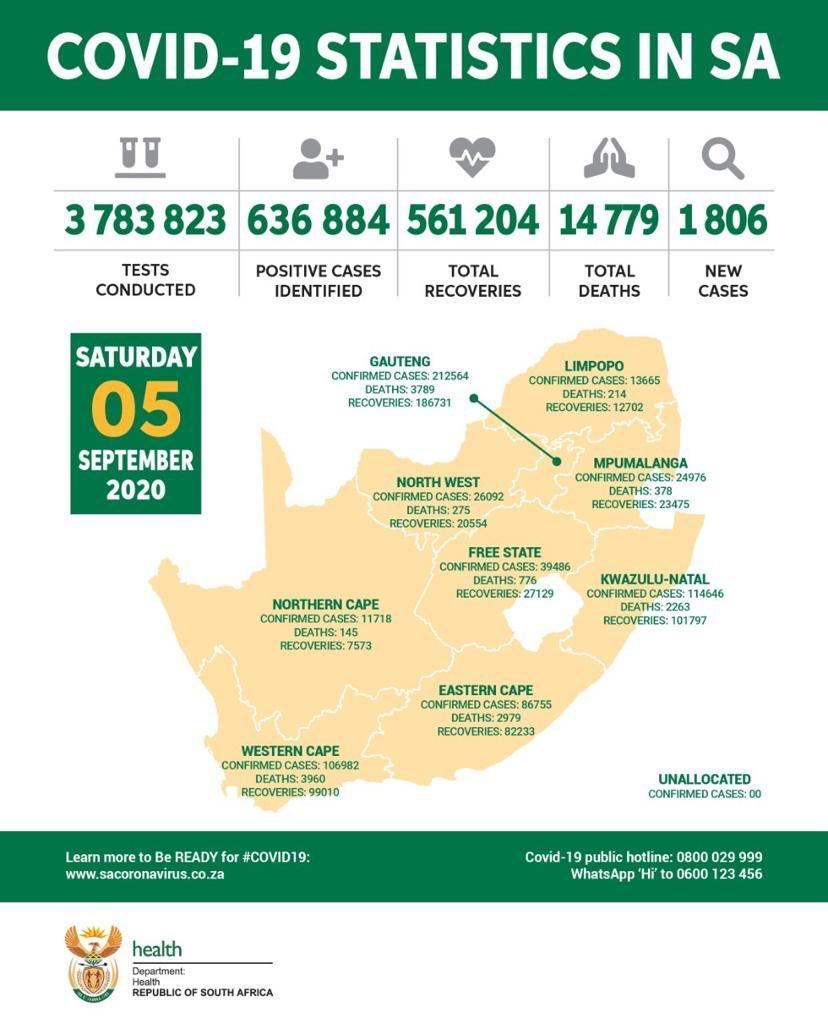In how many states, the number of confirmed cases crossed 100000?
Answer the question with a short phrase. 4 which state of South Africa has been reported highest number of recoveries? Gauteng which state of South Africa has been reported lowest number of deaths? Northern Cape which state of South Africa has been reported lowest number of confirmed cases? Northern Cape In how many states, the number of deaths crossed 1000? 4 In how many states, the number of recovered cases crossed 100000? 2 which state of South Africa has been reported highest number of deaths? Western Cape which state of South Africa has been reported more number of recovered cases - Western Cape or Eastern Cape? Western Cape What is the difference between number of confirmed cases  in Northern Cape and Eastern Cape? 75037 which state of South Africa has been reported lowest number of recoveries? Northern Cape which state of South Africa has been reported highest number of confirmed cases? Gauteng What is the difference between number of deaths in MPUMALANGA and NORTH WEST? 103 which state of South Africa has been reported less number of confirmed cases - Eastern Cape or Northern Cape? Northern Cape which state of South Africa has been reported more number of confirmed cases - Limpopo or Northern Cape? Limpopo 